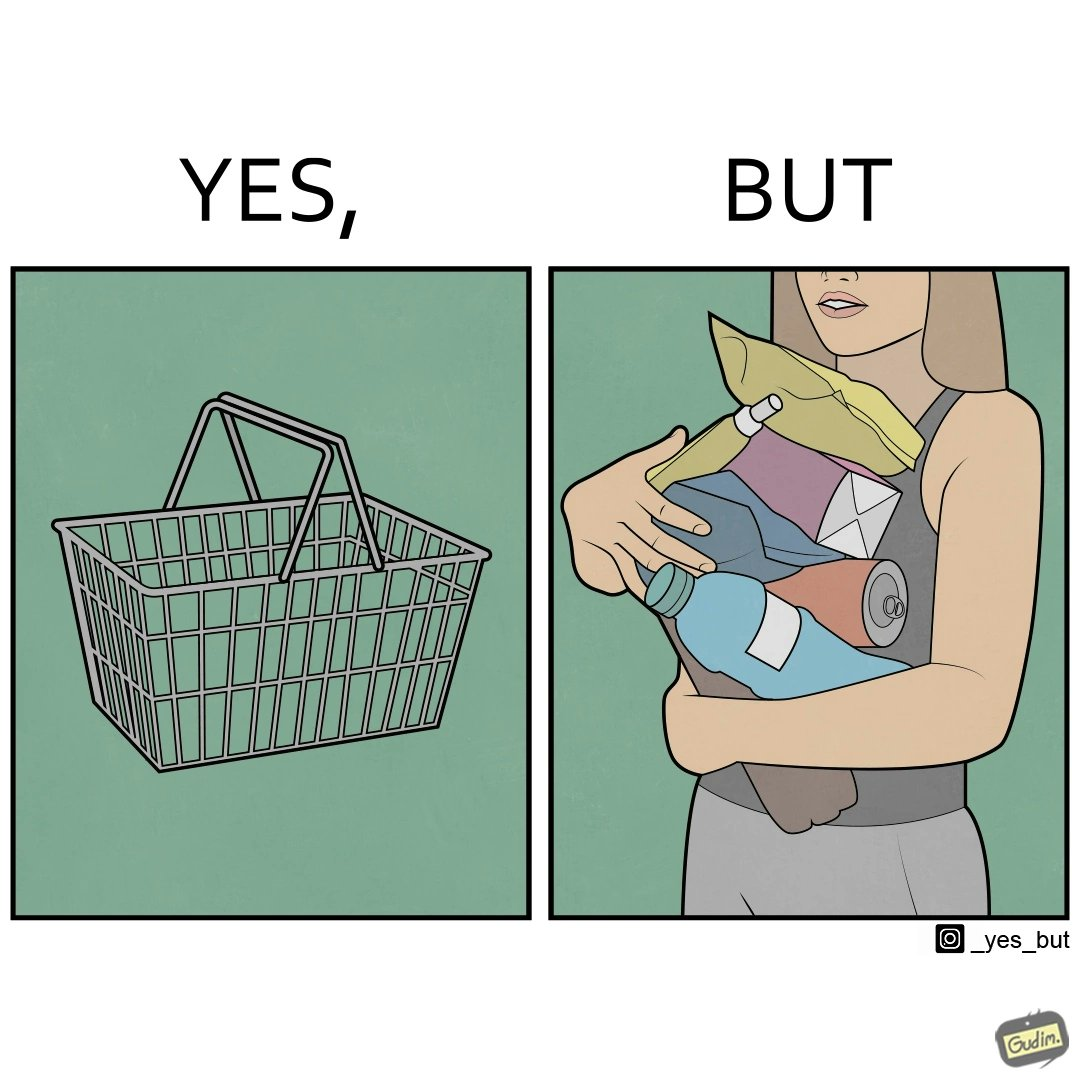Compare the left and right sides of this image. In the left part of the image: a steel frame basket In the right part of the image: a woman carrying many objects at once trying to hold them, and protecting them from falling off 